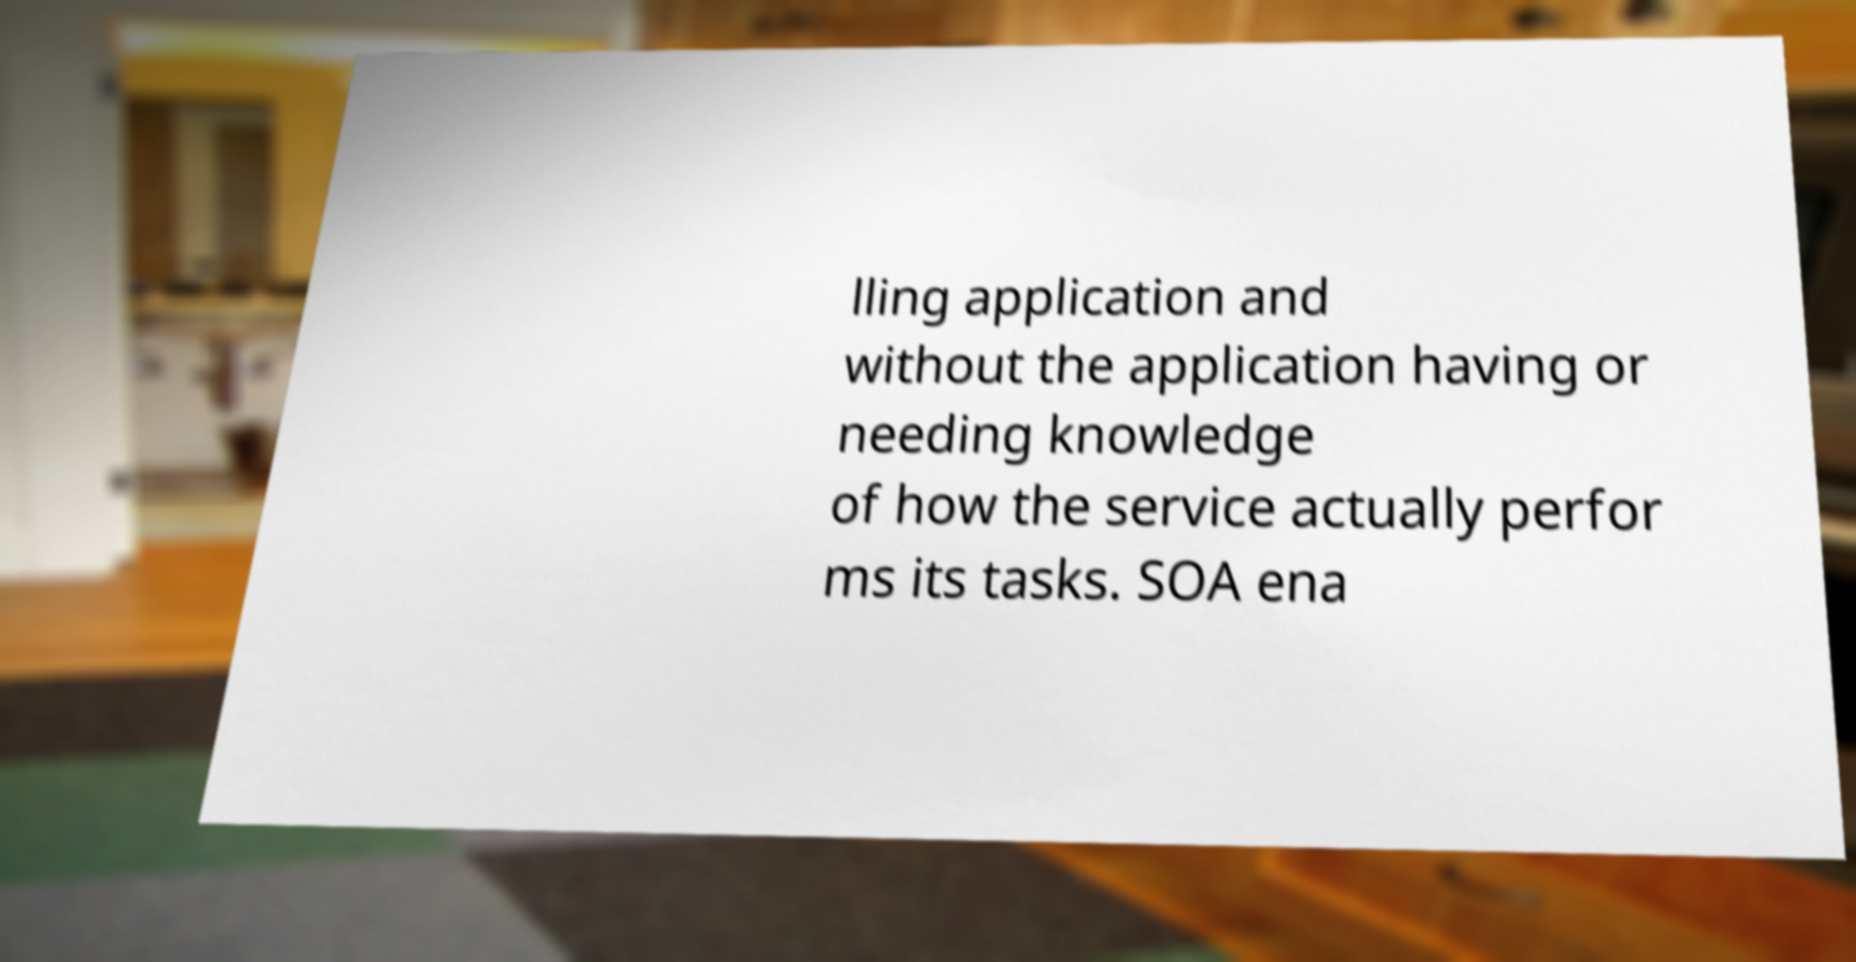There's text embedded in this image that I need extracted. Can you transcribe it verbatim? lling application and without the application having or needing knowledge of how the service actually perfor ms its tasks. SOA ena 